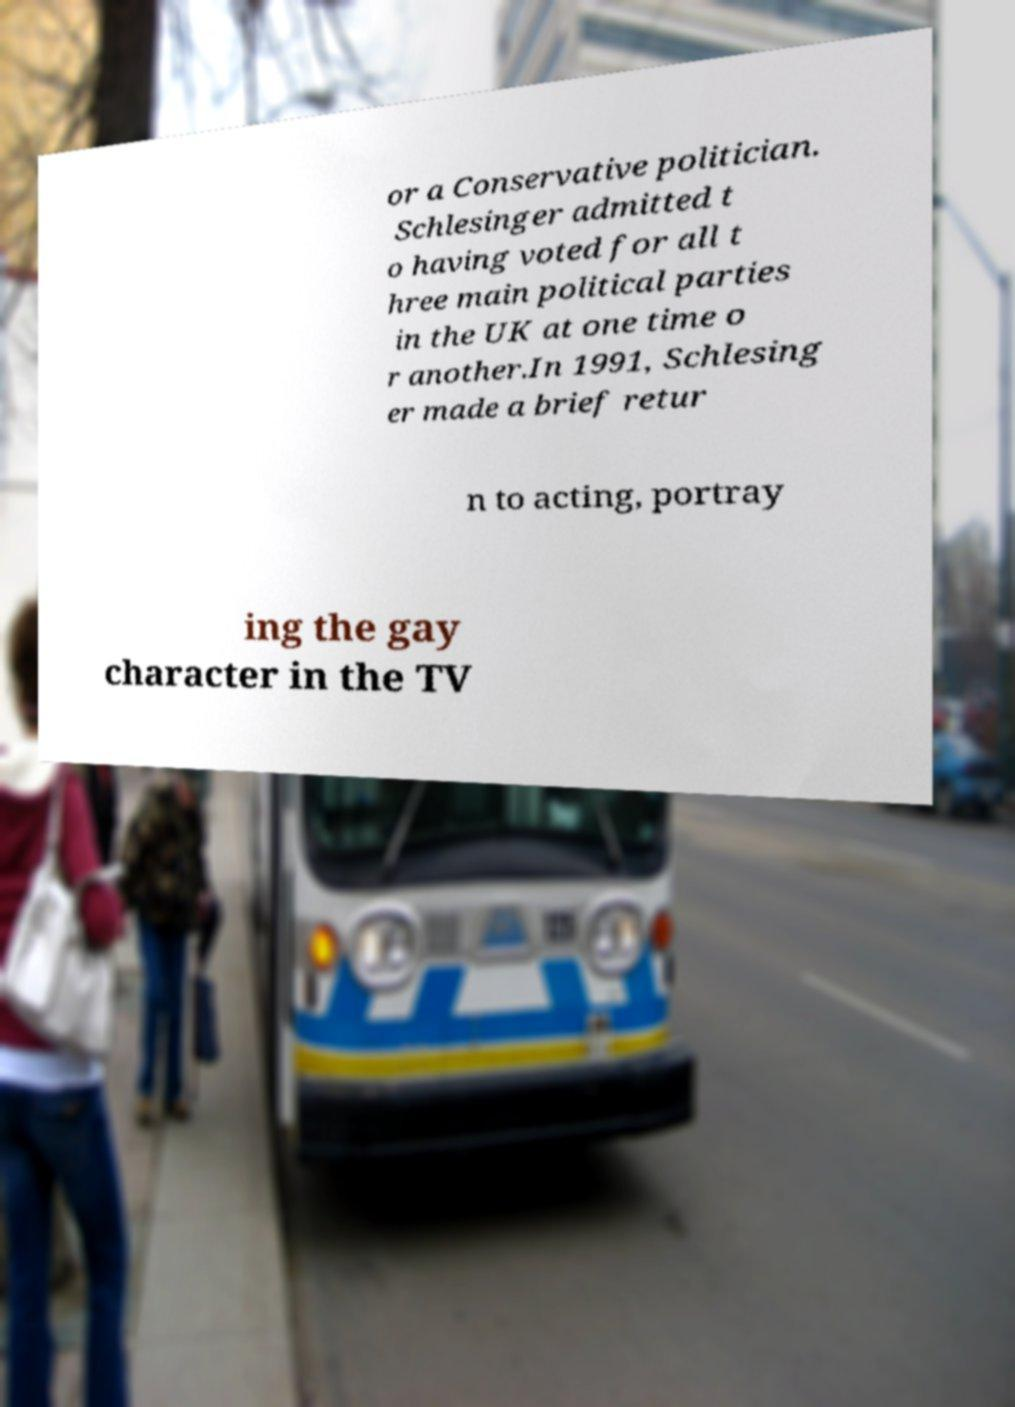Can you accurately transcribe the text from the provided image for me? or a Conservative politician. Schlesinger admitted t o having voted for all t hree main political parties in the UK at one time o r another.In 1991, Schlesing er made a brief retur n to acting, portray ing the gay character in the TV 